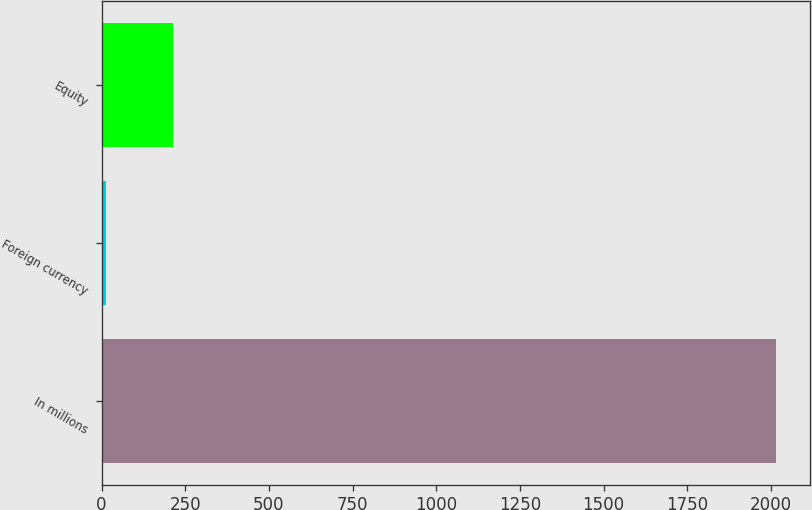<chart> <loc_0><loc_0><loc_500><loc_500><bar_chart><fcel>In millions<fcel>Foreign currency<fcel>Equity<nl><fcel>2015<fcel>14.6<fcel>214.64<nl></chart> 